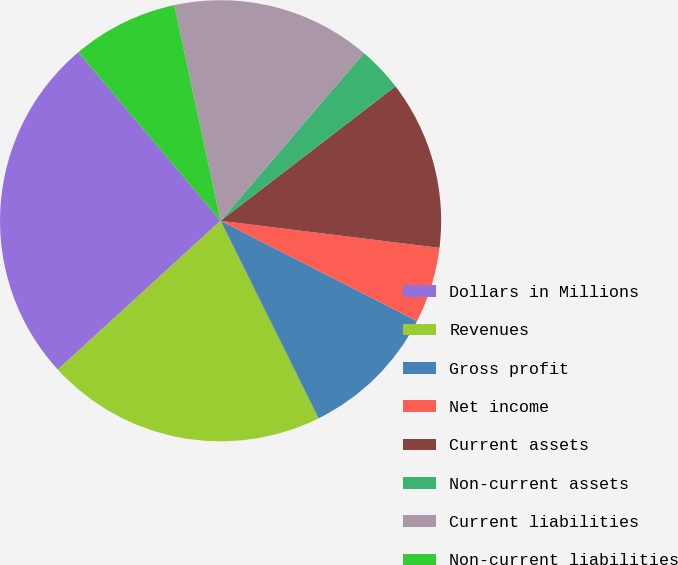Convert chart. <chart><loc_0><loc_0><loc_500><loc_500><pie_chart><fcel>Dollars in Millions<fcel>Revenues<fcel>Gross profit<fcel>Net income<fcel>Current assets<fcel>Non-current assets<fcel>Current liabilities<fcel>Non-current liabilities<nl><fcel>25.64%<fcel>20.54%<fcel>10.16%<fcel>5.55%<fcel>12.39%<fcel>3.31%<fcel>14.63%<fcel>7.78%<nl></chart> 